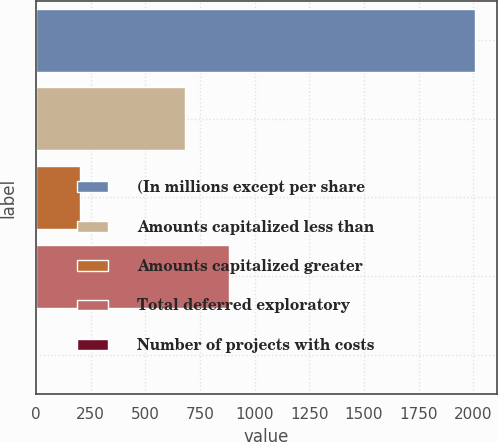<chart> <loc_0><loc_0><loc_500><loc_500><bar_chart><fcel>(In millions except per share<fcel>Amounts capitalized less than<fcel>Amounts capitalized greater<fcel>Total deferred exploratory<fcel>Number of projects with costs<nl><fcel>2007<fcel>683<fcel>203.4<fcel>883.4<fcel>3<nl></chart> 